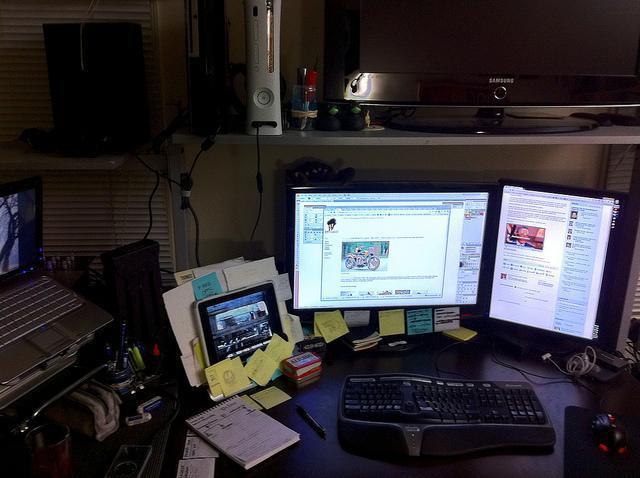How many monitors are seen?
Give a very brief answer. 3. How many keyboards are there?
Give a very brief answer. 2. How many laptops are in the photo?
Give a very brief answer. 2. How many tvs are there?
Give a very brief answer. 5. How many people are in the shot?
Give a very brief answer. 0. 